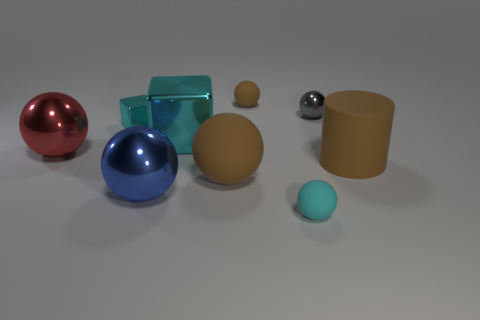Subtract 3 spheres. How many spheres are left? 3 Subtract all brown balls. How many balls are left? 4 Subtract all big brown rubber balls. How many balls are left? 5 Subtract all yellow balls. Subtract all blue cylinders. How many balls are left? 6 Subtract all blocks. How many objects are left? 7 Add 4 cyan blocks. How many cyan blocks are left? 6 Add 6 brown matte cylinders. How many brown matte cylinders exist? 7 Subtract 0 purple spheres. How many objects are left? 9 Subtract all tiny red things. Subtract all large blue spheres. How many objects are left? 8 